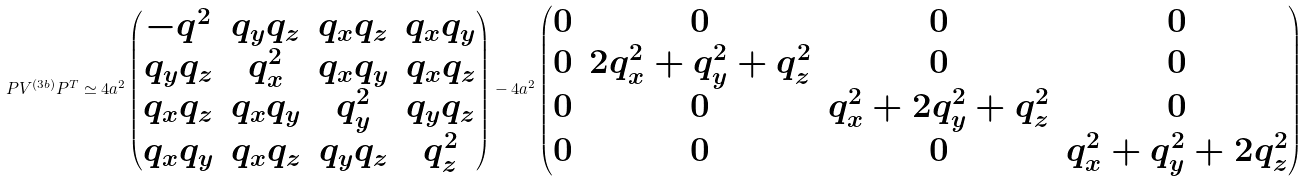Convert formula to latex. <formula><loc_0><loc_0><loc_500><loc_500>P V ^ { ( 3 b ) } P ^ { T } \simeq 4 a ^ { 2 } \begin{pmatrix} - q ^ { 2 } & q _ { y } q _ { z } & q _ { x } q _ { z } & q _ { x } q _ { y } \\ q _ { y } q _ { z } & q _ { x } ^ { 2 } & q _ { x } q _ { y } & q _ { x } q _ { z } \\ q _ { x } q _ { z } & q _ { x } q _ { y } & q _ { y } ^ { 2 } & q _ { y } q _ { z } \\ q _ { x } q _ { y } & q _ { x } q _ { z } & q _ { y } q _ { z } & q _ { z } ^ { 2 } \\ \end{pmatrix} - 4 a ^ { 2 } \begin{pmatrix} 0 & 0 & 0 & 0 \\ 0 & 2 q _ { x } ^ { 2 } + q _ { y } ^ { 2 } + q _ { z } ^ { 2 } & 0 & 0 \\ 0 & 0 & q _ { x } ^ { 2 } + 2 q _ { y } ^ { 2 } + q _ { z } ^ { 2 } & 0 \\ 0 & 0 & 0 & q _ { x } ^ { 2 } + q _ { y } ^ { 2 } + 2 q _ { z } ^ { 2 } \\ \end{pmatrix}</formula> 